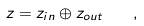<formula> <loc_0><loc_0><loc_500><loc_500>z = z _ { i n } \oplus z _ { o u t } \quad ,</formula> 